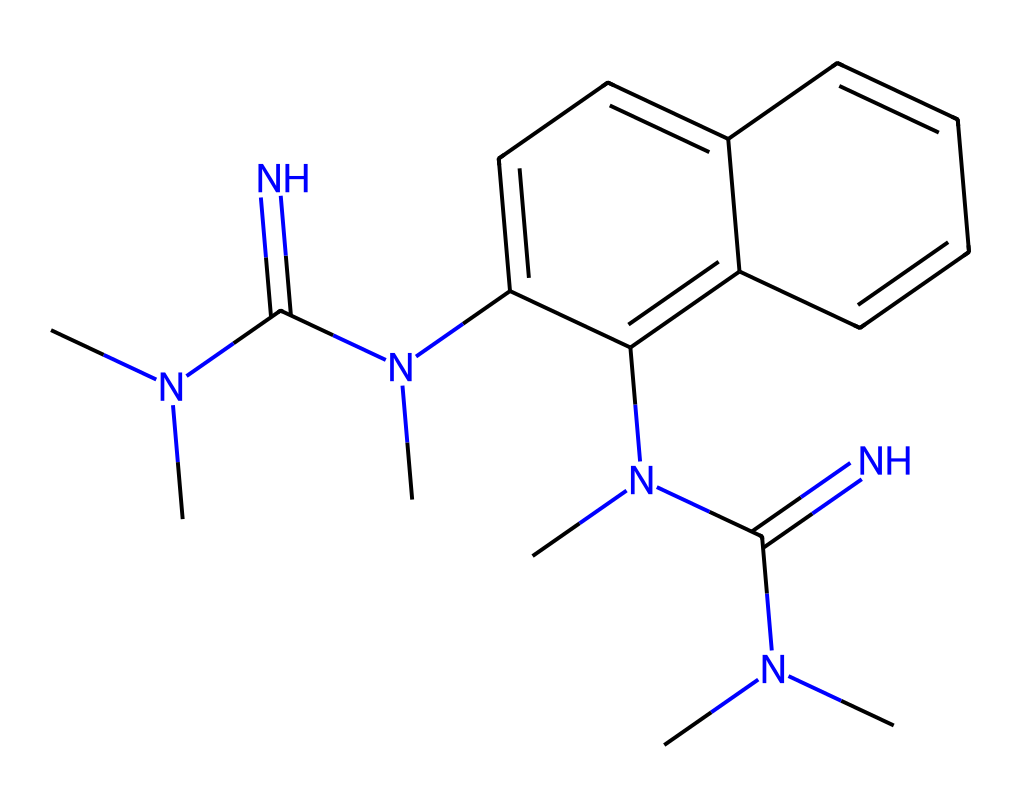What is the molecular formula of 1,8-bis(tetramethylguanidino)naphthalene? To determine the molecular formula, we analyze the provided SMILES. The structure contains multiple nitrogen, carbon, and hydrogen atoms. Counting these gives a total of 20 carbon (C), 28 hydrogen (H), and 4 nitrogen (N) atoms, resulting in the molecular formula C20H28N4.
Answer: C20H28N4 How many rings are present in the structure? By examining the SMILES representation, we can identify two fused naphthalene rings present in the structure. The notation indicates ring formation, leading to the conclusion that there are two rings in total.
Answer: 2 What types of functional groups are present in this molecule? Analyzing the structure, we find guanidine groups represented by the N(C)(C)C(=N) structure and aromatic rings. The presence of nitrogen with a double bond and the configuration indicates the presence of guanidine functional groups specifically.
Answer: guanidine Which atoms in the molecule are likely involved in protonation? The nitrogen atoms in the guanidine moieties are likely to be protonated due to their basic nature and ability to accept protons, making them key sites for protonation in the superbase structure.
Answer: nitrogen What is the total number of nitrogen atoms in 1,8-bis(tetramethylguanidino)naphthalene? By examining the SMILES representation, we count a total of 4 nitrogen atoms present in the molecule from the guanidine groups. This leads us to conclude that the total nitrogen count is four.
Answer: 4 